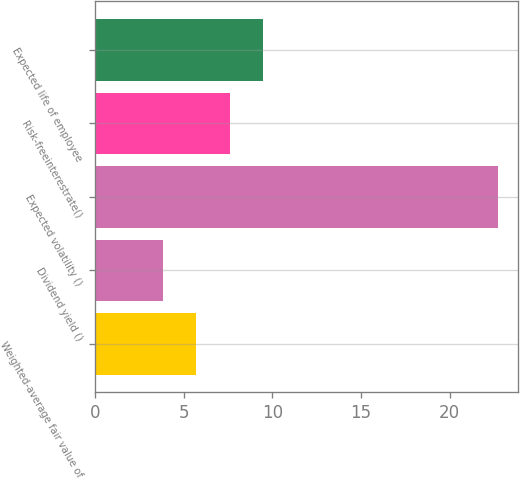Convert chart. <chart><loc_0><loc_0><loc_500><loc_500><bar_chart><fcel>Weighted-average fair value of<fcel>Dividend yield ()<fcel>Expected volatility ()<fcel>Risk-freeinterestrate()<fcel>Expected life of employee<nl><fcel>5.7<fcel>3.8<fcel>22.75<fcel>7.6<fcel>9.49<nl></chart> 